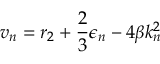<formula> <loc_0><loc_0><loc_500><loc_500>v _ { n } = r _ { 2 } + \frac { 2 } { 3 } \epsilon _ { n } - 4 \beta k _ { n } ^ { 2 }</formula> 